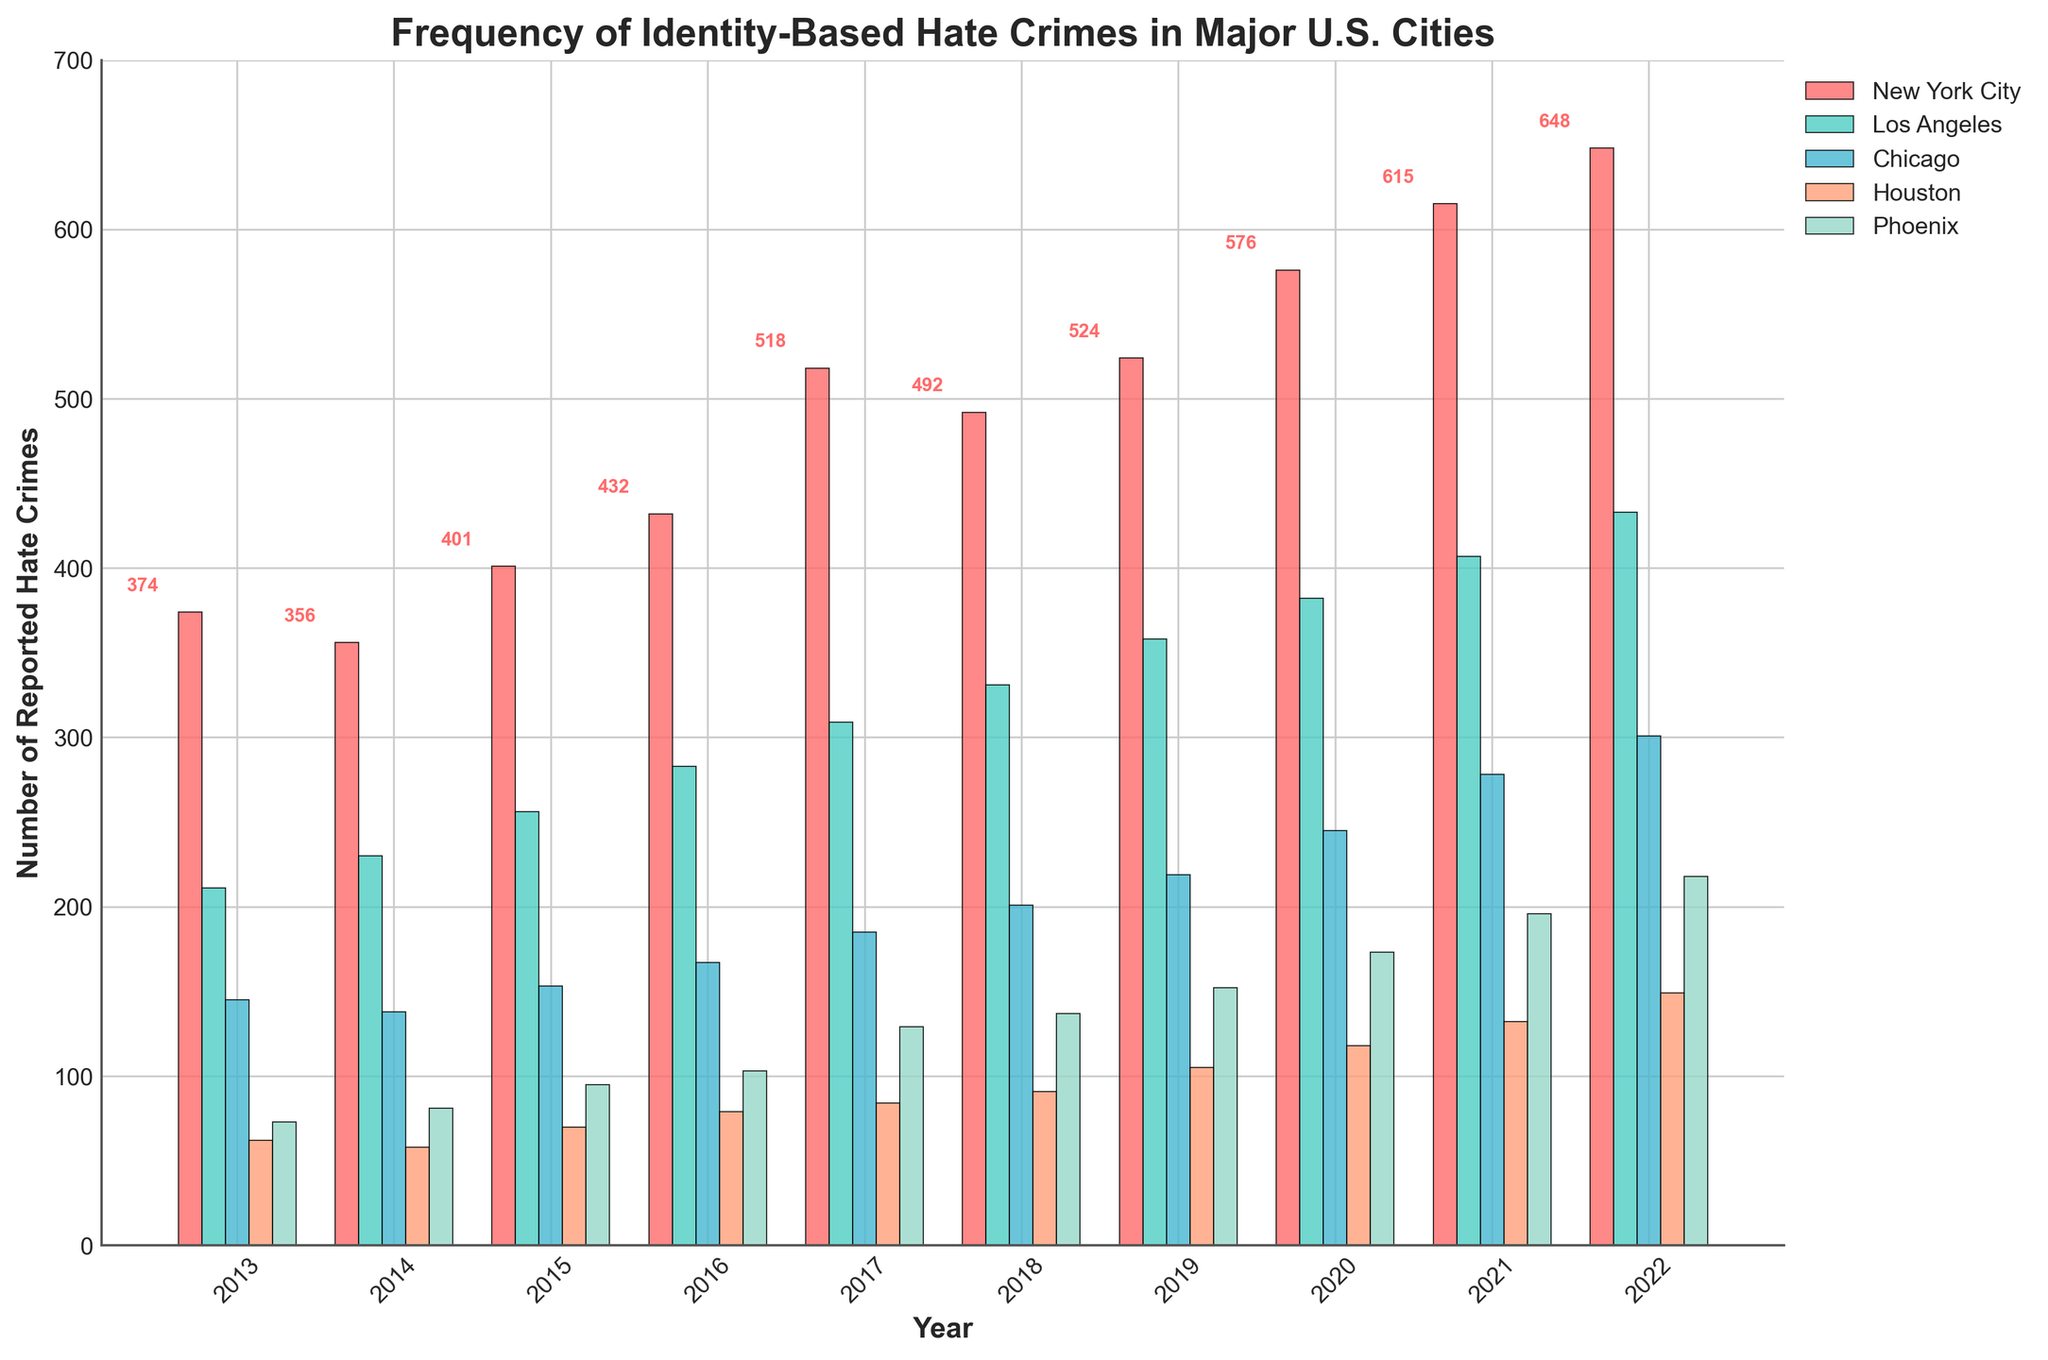What year had the highest number of reported hate crimes in New York City? To find the year with the highest number of reported hate crimes in New York City, look at the heights of the bars for New York City. The tallest bar represents the highest number for the city in the year 2022.
Answer: 2022 Which city had the fewest reported hate crimes in 2013? To determine this, look at the bars corresponding to the year 2013 for each city. The shortest bar is for Houston.
Answer: Houston In 2015, which city had a higher number of reported hate crimes, Phoenix or Chicago? Compare the bars representing Phoenix and Chicago for the year 2015. The bar for Chicago (153) is taller than the one for Phoenix (95).
Answer: Chicago What is the total number of reported hate crimes across all cities in 2020? Add the reported hate crimes for each city in 2020: 576 (New York City) + 382 (Los Angeles) + 245 (Chicago) + 118 (Houston) + 173 (Phoenix). The total is 1494.
Answer: 1494 How did the number of reported hate crimes change in Houston from 2019 to 2020? Subtract the number of hate crimes in 2019 from the number in 2020 for Houston: 118 (2020) - 105 (2019). The change is an increase of 13.
Answer: Increased by 13 Which city showed a consistent increase in reported hate crimes every year from 2013 to 2022? Look for the city where the height of the bars increases every year. New York City's bars increase steadily each year.
Answer: New York City Between 2018 and 2019, did Los Angeles see an increase, decrease, or no change in the number of reported hate crimes? Compare the heights of the bars for Los Angeles in 2018 and 2019. The bar for 2019 (358) is taller than the bar for 2018 (331).
Answer: Increase In 2021, which city had fewer reported hate crimes than Phoenix? Compare the height of Phoenix's bar in 2021 (196) with other cities. Houston (132) had fewer reported hate crimes.
Answer: Houston What is the average number of reported hate crimes in New York City over the decade? Add New York City's reported hate crimes from 2013 to 2022: 374 + 356 + 401 + 432 + 518 + 492 + 524 + 576 + 615 + 648 = 4936. Divide the total by 10. The average is 493.6.
Answer: 493.6 